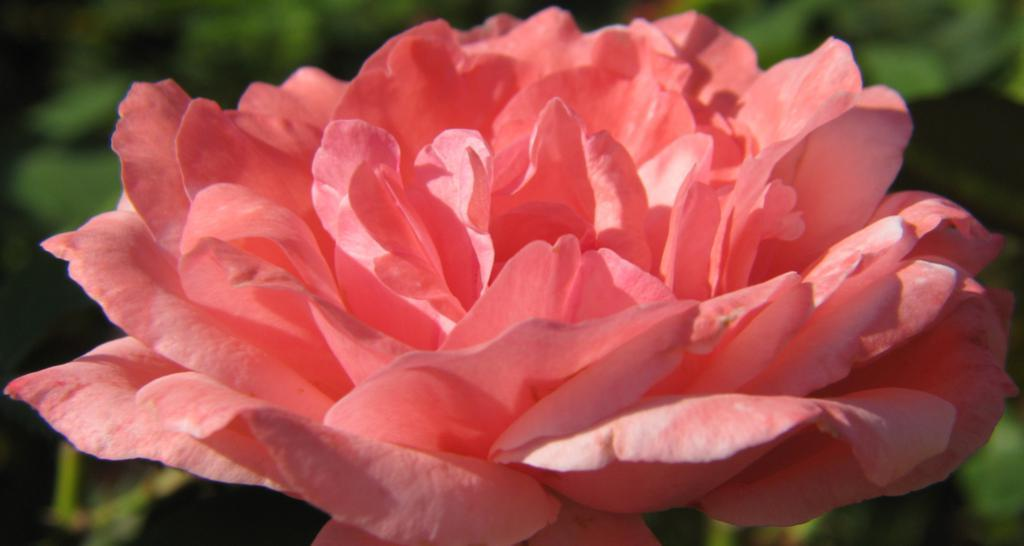What is the main subject of the image? There is a flower in the image. What can be seen in the background of the image? There are plants in the background of the image. How would you describe the quality of the image? The image is blurry. How many snakes are slithering around the flower in the image? There are no snakes present in the image; it features a flower and plants in the background. 